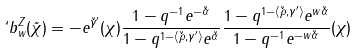Convert formula to latex. <formula><loc_0><loc_0><loc_500><loc_500>` b _ { w } ^ { Z } ( \tilde { \chi } ) = - e ^ { \check { \gamma } ^ { \prime } } ( \chi ) \frac { 1 - q ^ { - 1 } e ^ { - \check { \alpha } } } { 1 - q ^ { 1 - \left < \check { \rho } , \gamma ^ { \prime } \right > } e ^ { \check { \alpha } } } \frac { 1 - q ^ { 1 - \left < \check { \rho } , \gamma ^ { \prime } \right > } e ^ { w \check { \alpha } } } { 1 - q ^ { - 1 } e ^ { - w \check { \alpha } } } ( \chi )</formula> 